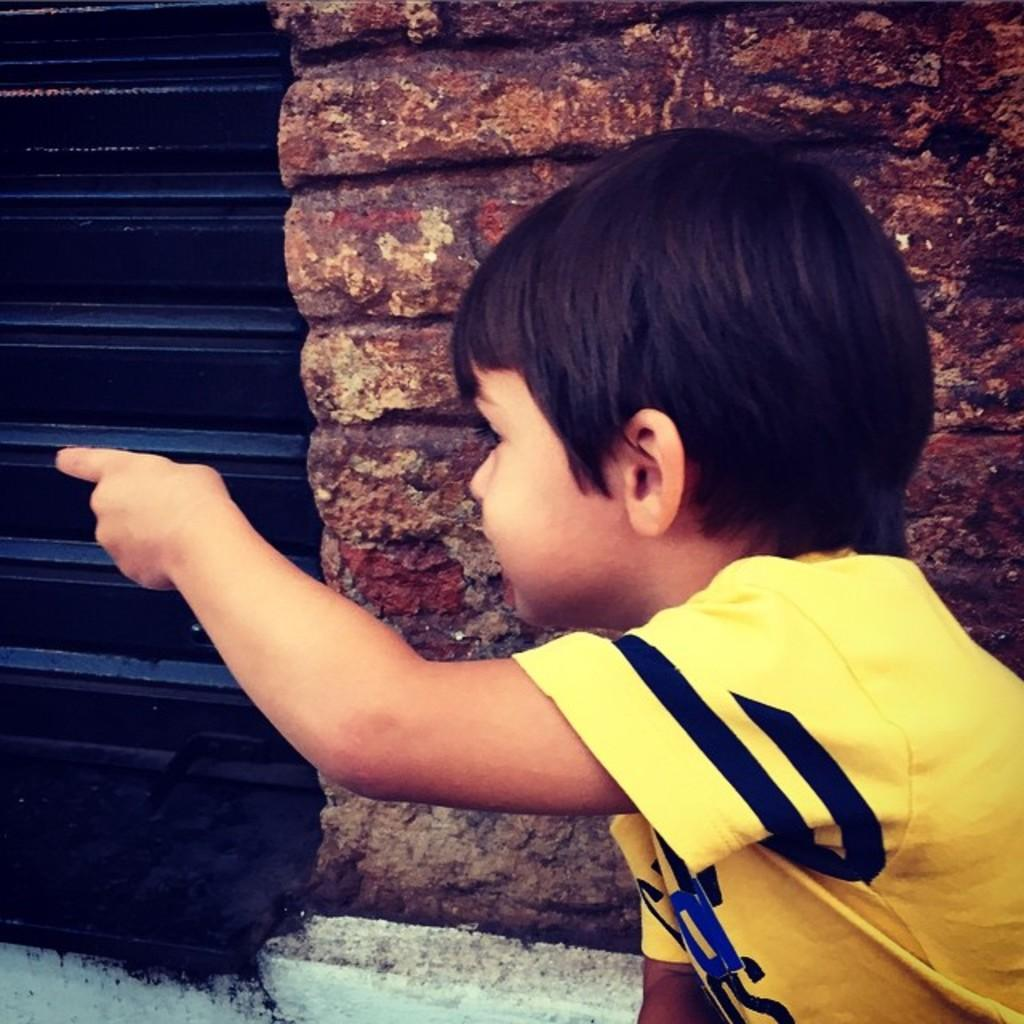What is the main subject of the image? The main subject of the image is a kid. What is the kid wearing in the image? The kid is wearing a yellow t-shirt in the image. What action is the kid performing in the image? The kid is pointing a finger to the left in the image. What can be seen in the background of the image? There is a wall and a shutter in the background of the image. Can you see the ocean in the background of the image? No, there is no ocean visible in the background of the image. How many breaths is the kid taking in the image? It is not possible to determine the number of breaths the kid is taking from the image. 